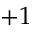Convert formula to latex. <formula><loc_0><loc_0><loc_500><loc_500>+ 1</formula> 